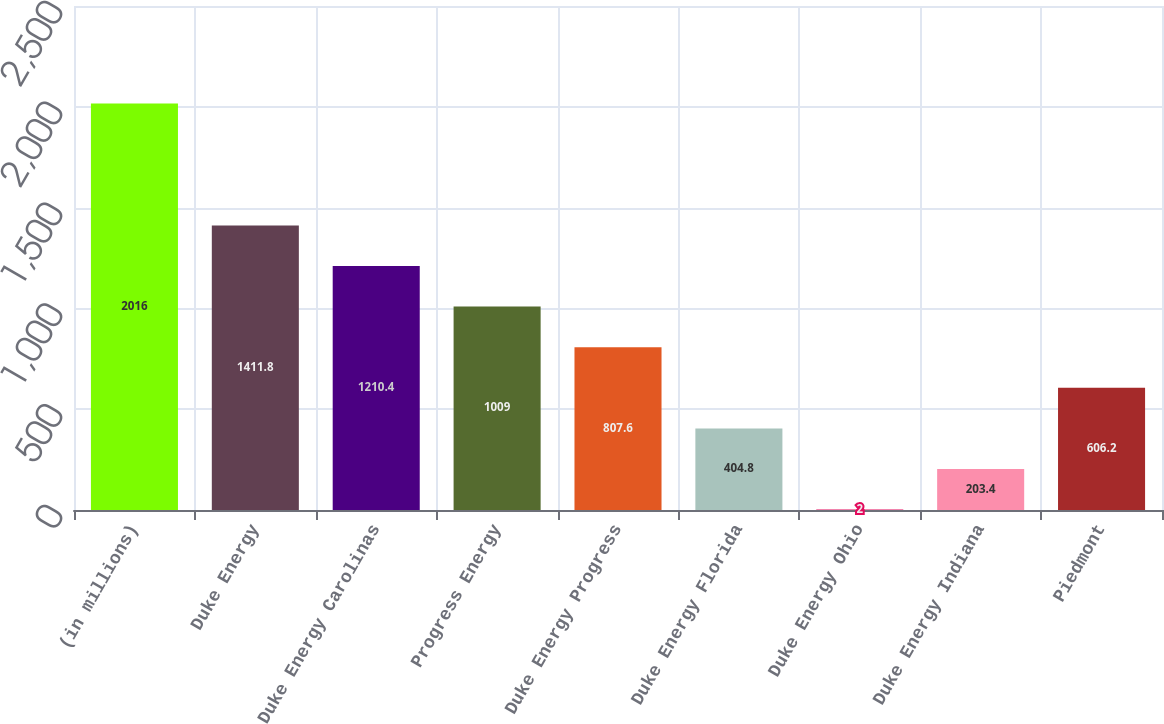Convert chart to OTSL. <chart><loc_0><loc_0><loc_500><loc_500><bar_chart><fcel>(in millions)<fcel>Duke Energy<fcel>Duke Energy Carolinas<fcel>Progress Energy<fcel>Duke Energy Progress<fcel>Duke Energy Florida<fcel>Duke Energy Ohio<fcel>Duke Energy Indiana<fcel>Piedmont<nl><fcel>2016<fcel>1411.8<fcel>1210.4<fcel>1009<fcel>807.6<fcel>404.8<fcel>2<fcel>203.4<fcel>606.2<nl></chart> 